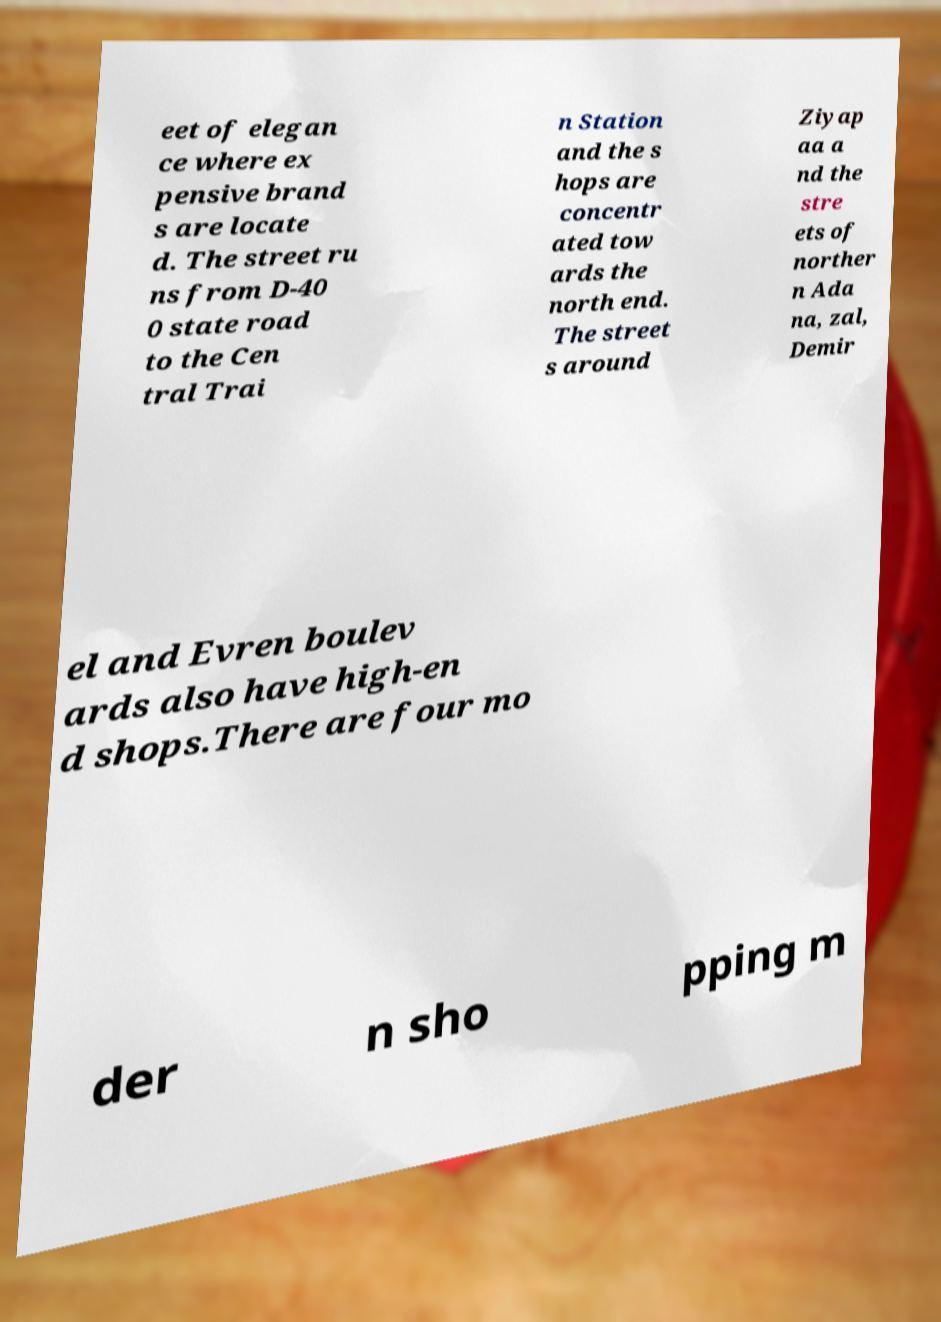I need the written content from this picture converted into text. Can you do that? eet of elegan ce where ex pensive brand s are locate d. The street ru ns from D-40 0 state road to the Cen tral Trai n Station and the s hops are concentr ated tow ards the north end. The street s around Ziyap aa a nd the stre ets of norther n Ada na, zal, Demir el and Evren boulev ards also have high-en d shops.There are four mo der n sho pping m 